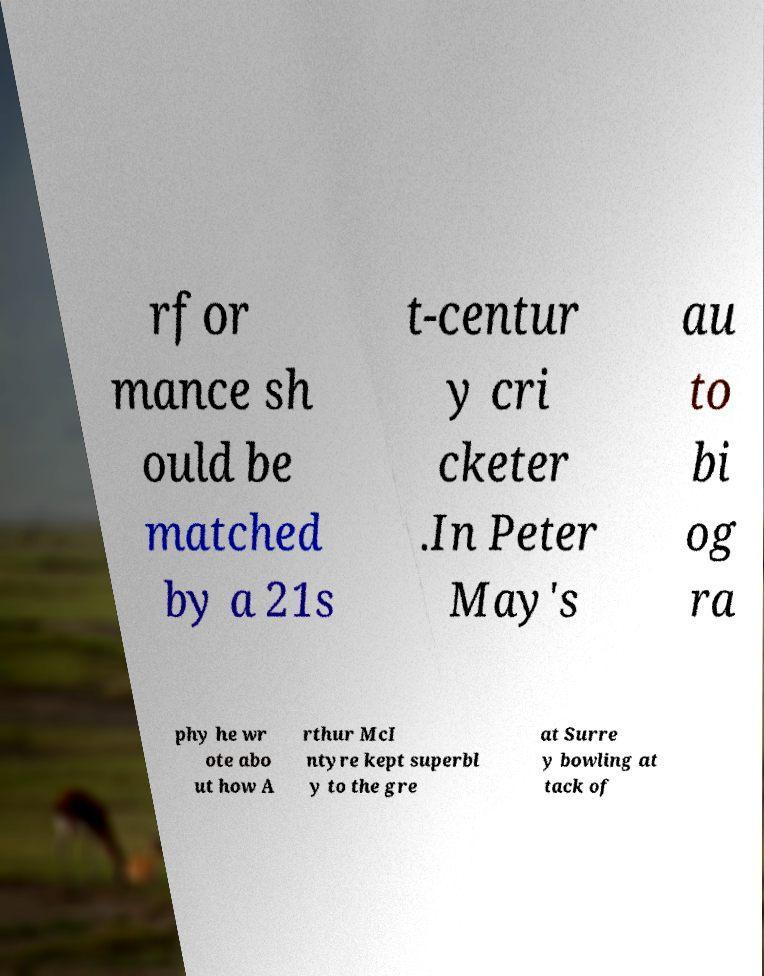For documentation purposes, I need the text within this image transcribed. Could you provide that? rfor mance sh ould be matched by a 21s t-centur y cri cketer .In Peter May's au to bi og ra phy he wr ote abo ut how A rthur McI ntyre kept superbl y to the gre at Surre y bowling at tack of 